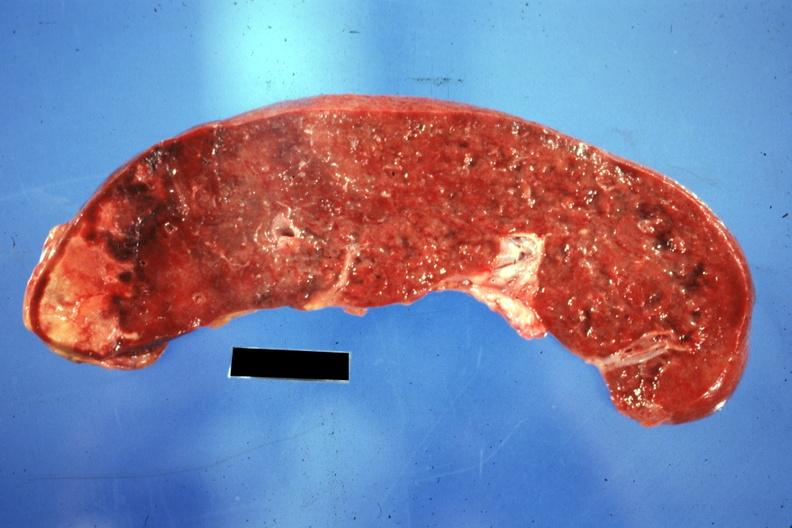what is present?
Answer the question using a single word or phrase. Hematologic 